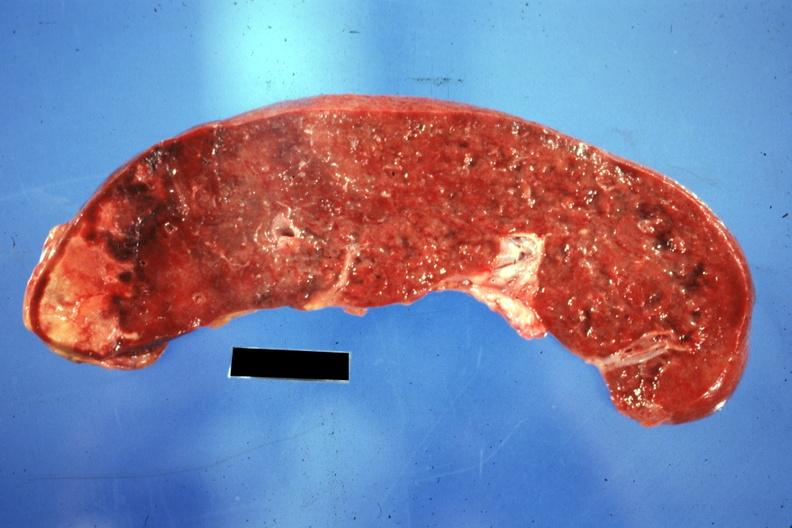what is present?
Answer the question using a single word or phrase. Hematologic 